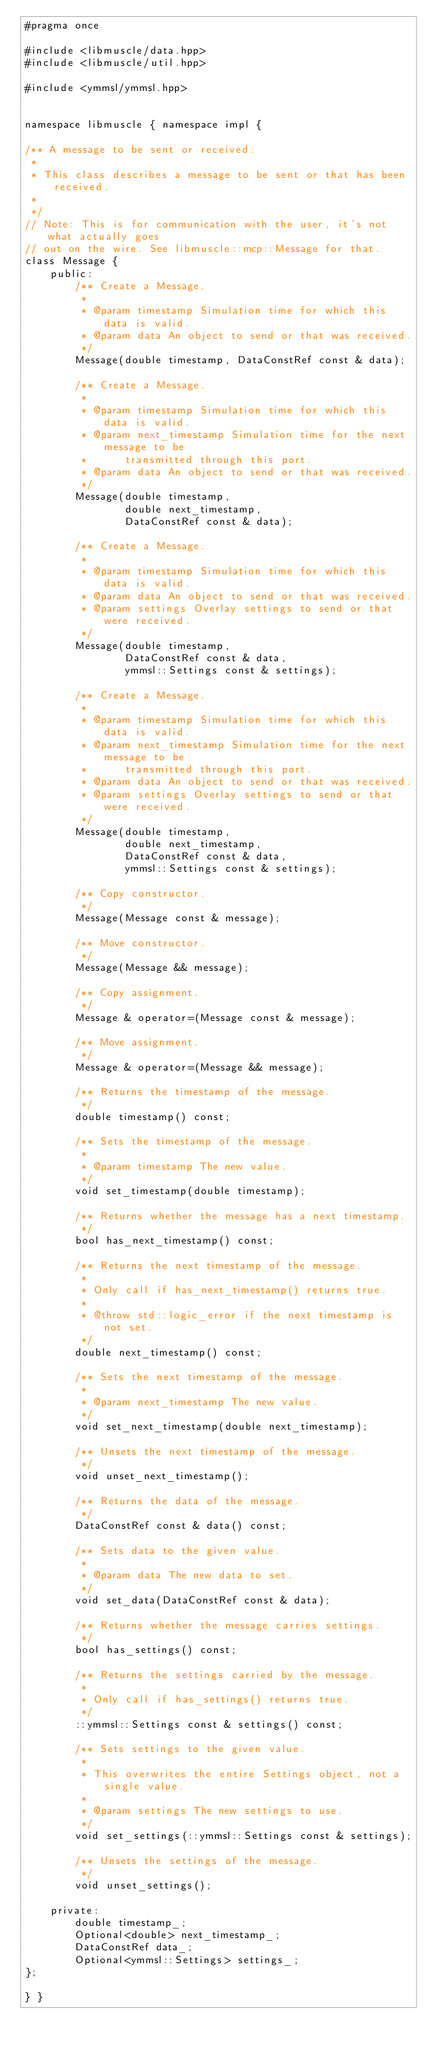Convert code to text. <code><loc_0><loc_0><loc_500><loc_500><_C++_>#pragma once

#include <libmuscle/data.hpp>
#include <libmuscle/util.hpp>

#include <ymmsl/ymmsl.hpp>


namespace libmuscle { namespace impl {

/** A message to be sent or received.
 *
 * This class describes a message to be sent or that has been received.
 *
 */
// Note: This is for communication with the user, it's not what actually goes
// out on the wire. See libmuscle::mcp::Message for that.
class Message {
    public:
        /** Create a Message.
         *
         * @param timestamp Simulation time for which this data is valid.
         * @param data An object to send or that was received.
         */
        Message(double timestamp, DataConstRef const & data);

        /** Create a Message.
         *
         * @param timestamp Simulation time for which this data is valid.
         * @param next_timestamp Simulation time for the next message to be
         *      transmitted through this port.
         * @param data An object to send or that was received.
         */
        Message(double timestamp,
                double next_timestamp,
                DataConstRef const & data);

        /** Create a Message.
         *
         * @param timestamp Simulation time for which this data is valid.
         * @param data An object to send or that was received.
         * @param settings Overlay settings to send or that were received.
         */
        Message(double timestamp,
                DataConstRef const & data,
                ymmsl::Settings const & settings);

        /** Create a Message.
         *
         * @param timestamp Simulation time for which this data is valid.
         * @param next_timestamp Simulation time for the next message to be
         *      transmitted through this port.
         * @param data An object to send or that was received.
         * @param settings Overlay settings to send or that were received.
         */
        Message(double timestamp,
                double next_timestamp,
                DataConstRef const & data,
                ymmsl::Settings const & settings);

        /** Copy constructor.
         */
        Message(Message const & message);

        /** Move constructor.
         */
        Message(Message && message);

        /** Copy assignment.
         */
        Message & operator=(Message const & message);

        /** Move assignment.
         */
        Message & operator=(Message && message);

        /** Returns the timestamp of the message.
         */
        double timestamp() const;

        /** Sets the timestamp of the message.
         *
         * @param timestamp The new value.
         */
        void set_timestamp(double timestamp);

        /** Returns whether the message has a next timestamp.
         */
        bool has_next_timestamp() const;

        /** Returns the next timestamp of the message.
         *
         * Only call if has_next_timestamp() returns true.
         *
         * @throw std::logic_error if the next timestamp is not set.
         */
        double next_timestamp() const;

        /** Sets the next timestamp of the message.
         *
         * @param next_timestamp The new value.
         */
        void set_next_timestamp(double next_timestamp);

        /** Unsets the next timestamp of the message.
         */
        void unset_next_timestamp();

        /** Returns the data of the message.
         */
        DataConstRef const & data() const;

        /** Sets data to the given value.
         *
         * @param data The new data to set.
         */
        void set_data(DataConstRef const & data);

        /** Returns whether the message carries settings.
         */
        bool has_settings() const;

        /** Returns the settings carried by the message.
         *
         * Only call if has_settings() returns true.
         */
        ::ymmsl::Settings const & settings() const;

        /** Sets settings to the given value.
         *
         * This overwrites the entire Settings object, not a single value.
         *
         * @param settings The new settings to use.
         */
        void set_settings(::ymmsl::Settings const & settings);

        /** Unsets the settings of the message.
         */
        void unset_settings();

    private:
        double timestamp_;
        Optional<double> next_timestamp_;
        DataConstRef data_;
        Optional<ymmsl::Settings> settings_;
};

} }

</code> 